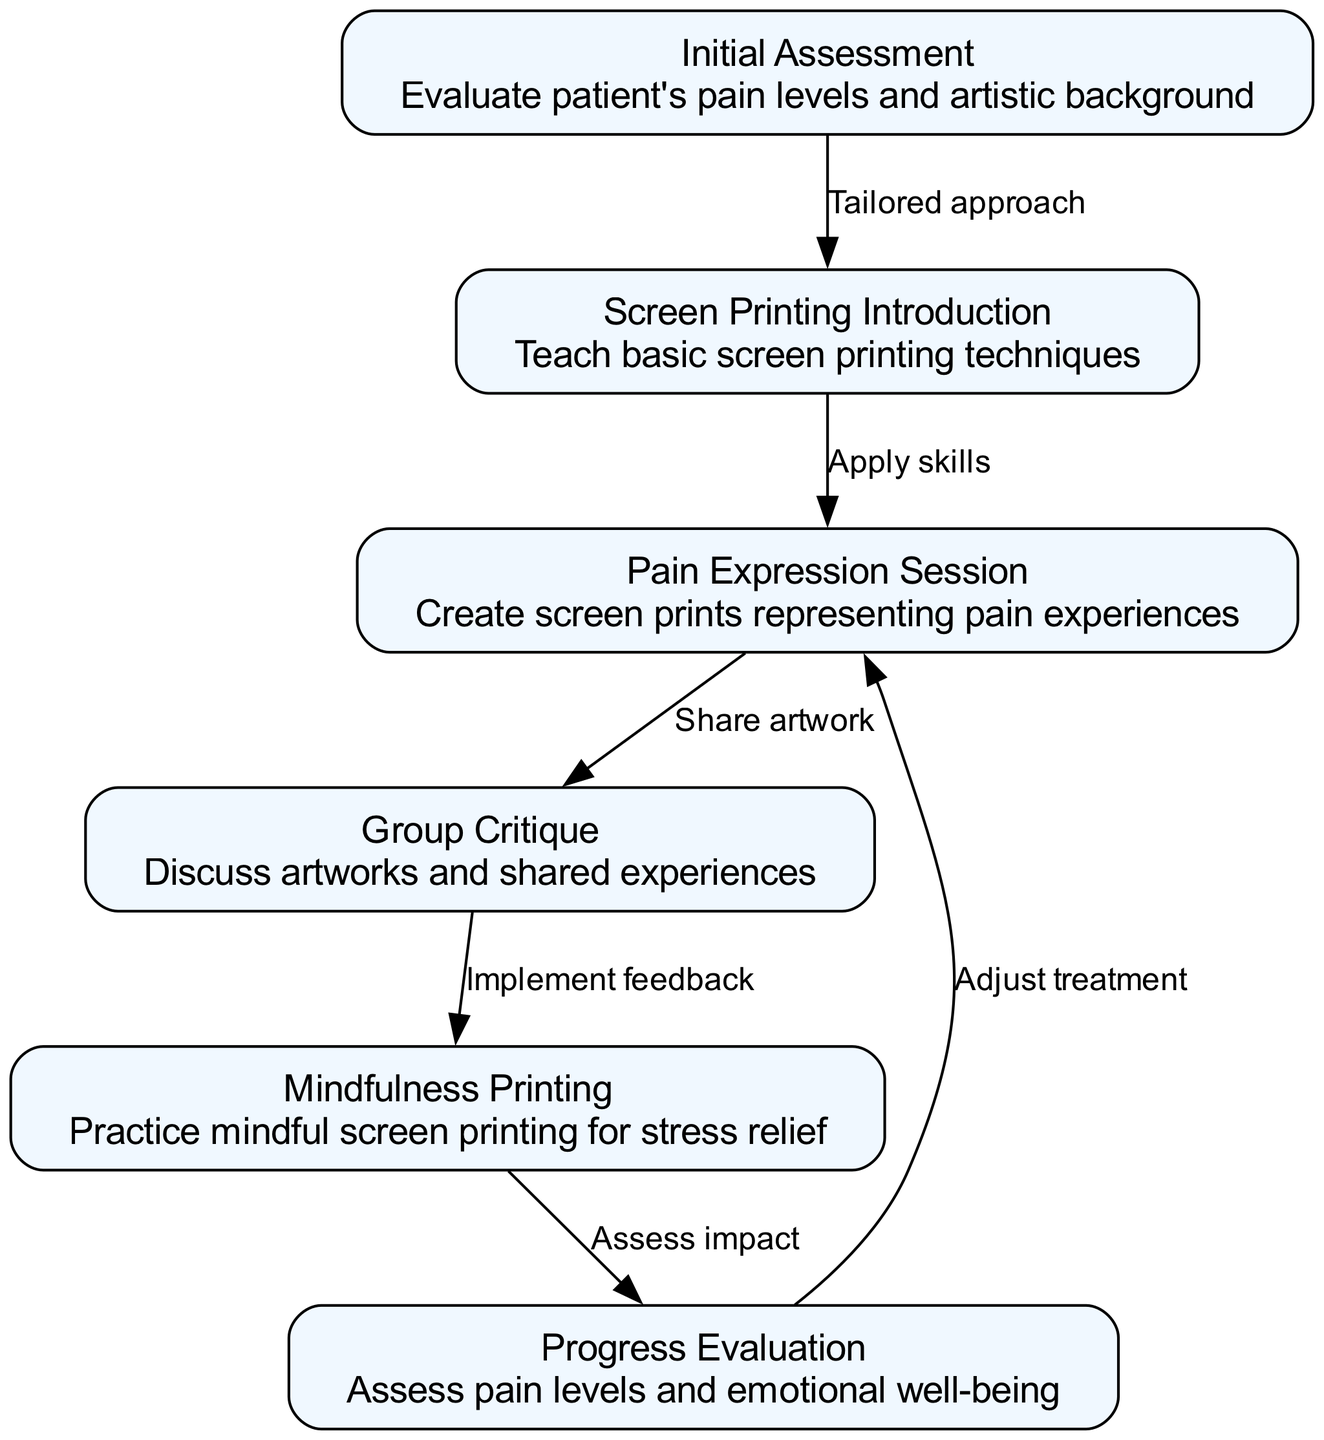What is the first step in the pathway? The diagram shows 'Initial Assessment' as the first node, indicating that it is the starting point of the treatment plan.
Answer: Initial Assessment How many nodes are in the diagram? By counting the nodes listed, we find there are six distinct nodes representing different steps in the treatment pathway.
Answer: 6 What is the last node in the clinical pathway? The last node is 'Progress Evaluation', which signifies the final assessment of the patient's status during the treatment journey.
Answer: Progress Evaluation Which node represents the evaluation of pain levels and emotional well-being? The node labeled 'Progress Evaluation' is where the assessment of pain levels and emotional well-being occurs, as noted in its details.
Answer: Progress Evaluation What is the relationship between 'Pain Expression Session' and 'Group Critique'? The diagram shows an edge from 'Pain Expression Session' to 'Group Critique', meaning that the artwork created in the pain expression session is shared and discussed in the critique session.
Answer: Share artwork What action is taken after the 'Group Critique'? The pathway indicates an implementation of feedback in the next step, denoting adjustments made based on the discussion outcomes of the group critique.
Answer: Implement feedback What element leads to 'Mindfulness Printing'? The edge stemming from 'Group Critique' directs towards 'Mindfulness Printing', suggesting that insights from the critique inform the subsequent mindful printing activities.
Answer: Implement feedback How do you adjust treatment based on the clinical pathway? The diagram shows a feedback loop from 'Progress Evaluation' back to 'Pain Expression Session', indicating that treatment adjustments follow the evaluation of patient progress.
Answer: Adjust treatment 